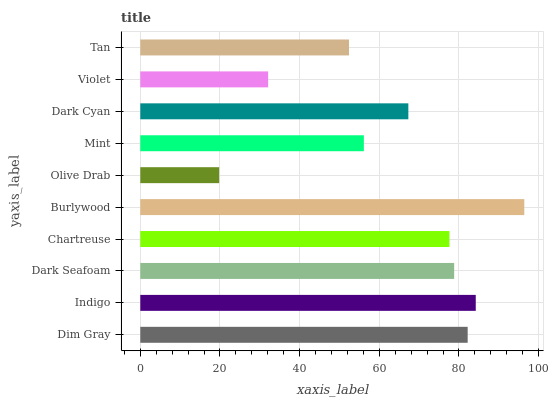Is Olive Drab the minimum?
Answer yes or no. Yes. Is Burlywood the maximum?
Answer yes or no. Yes. Is Indigo the minimum?
Answer yes or no. No. Is Indigo the maximum?
Answer yes or no. No. Is Indigo greater than Dim Gray?
Answer yes or no. Yes. Is Dim Gray less than Indigo?
Answer yes or no. Yes. Is Dim Gray greater than Indigo?
Answer yes or no. No. Is Indigo less than Dim Gray?
Answer yes or no. No. Is Chartreuse the high median?
Answer yes or no. Yes. Is Dark Cyan the low median?
Answer yes or no. Yes. Is Tan the high median?
Answer yes or no. No. Is Mint the low median?
Answer yes or no. No. 